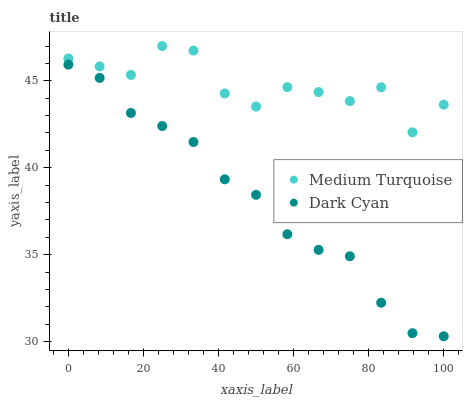Does Dark Cyan have the minimum area under the curve?
Answer yes or no. Yes. Does Medium Turquoise have the maximum area under the curve?
Answer yes or no. Yes. Does Medium Turquoise have the minimum area under the curve?
Answer yes or no. No. Is Dark Cyan the smoothest?
Answer yes or no. Yes. Is Medium Turquoise the roughest?
Answer yes or no. Yes. Is Medium Turquoise the smoothest?
Answer yes or no. No. Does Dark Cyan have the lowest value?
Answer yes or no. Yes. Does Medium Turquoise have the lowest value?
Answer yes or no. No. Does Medium Turquoise have the highest value?
Answer yes or no. Yes. Is Dark Cyan less than Medium Turquoise?
Answer yes or no. Yes. Is Medium Turquoise greater than Dark Cyan?
Answer yes or no. Yes. Does Dark Cyan intersect Medium Turquoise?
Answer yes or no. No. 